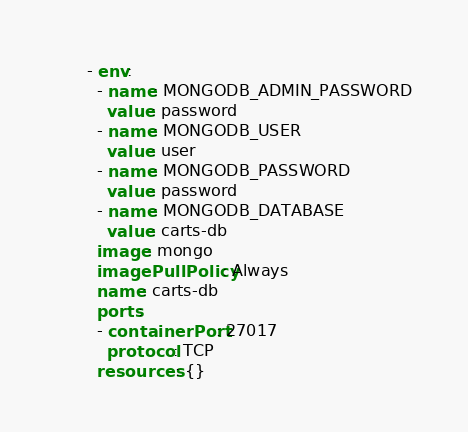<code> <loc_0><loc_0><loc_500><loc_500><_YAML_>      - env:
        - name: MONGODB_ADMIN_PASSWORD
          value: password
        - name: MONGODB_USER
          value: user
        - name: MONGODB_PASSWORD
          value: password
        - name: MONGODB_DATABASE
          value: carts-db
        image: mongo
        imagePullPolicy: Always
        name: carts-db
        ports:
        - containerPort: 27017
          protocol: TCP
        resources: {}</code> 